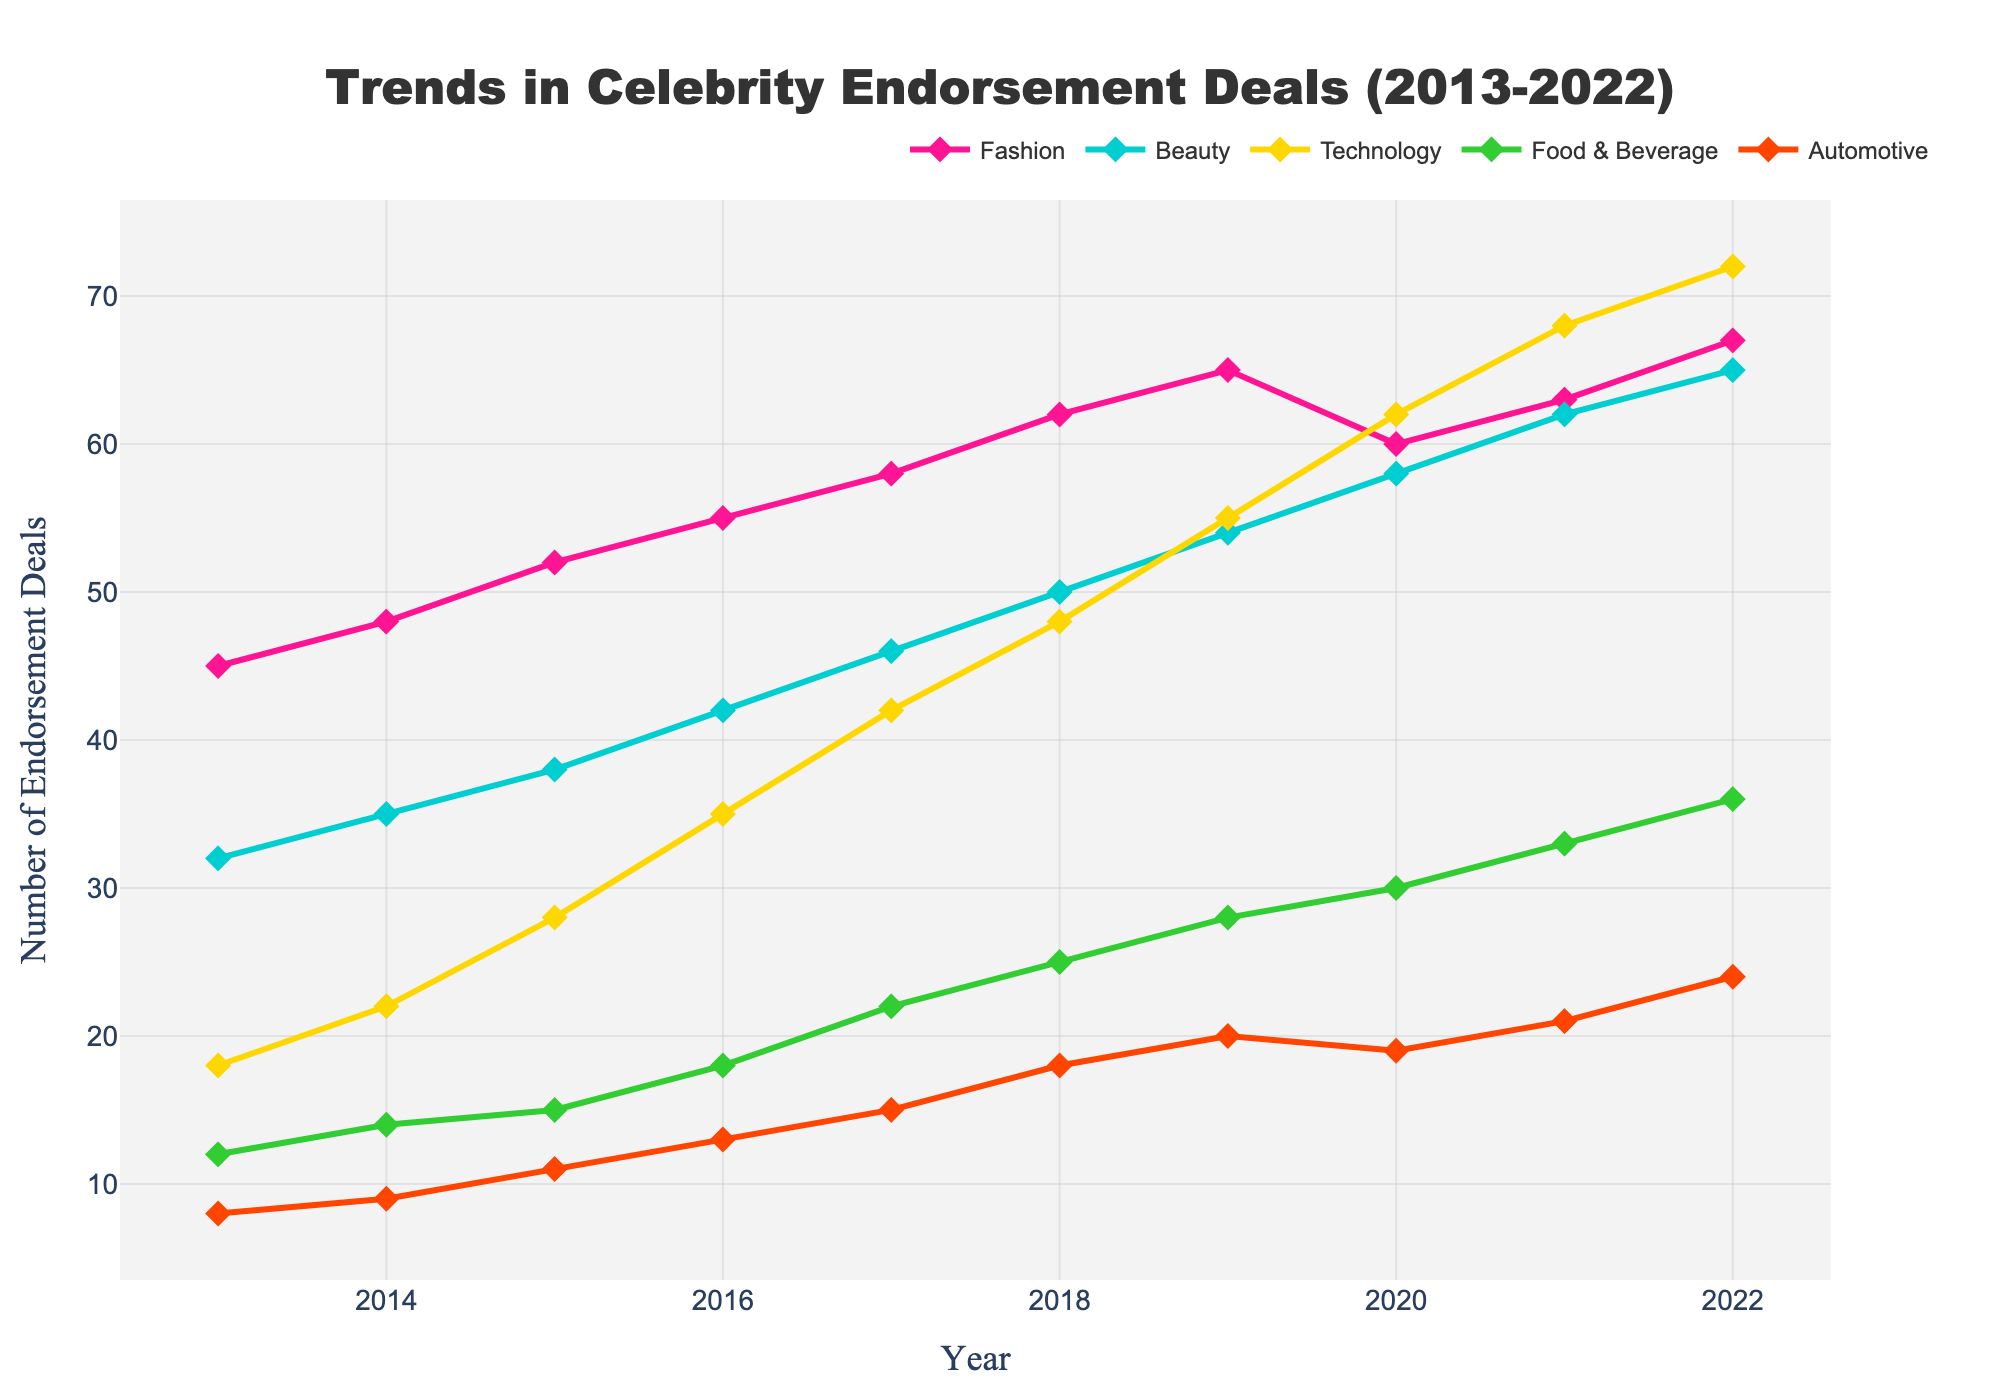Which industry had the highest number of celebrity endorsement deals in 2022? Look at the endpoints of each line in 2022 and identify the one with the highest value. Technology has the highest value at 72.
Answer: Technology Which industry saw the least increase in endorsement deals from 2013 to 2022? Calculate the increase for each industry by subtracting the 2013 value from the 2022 value. The increases are: Fashion (22), Beauty (33), Technology (54), Food & Beverage (24), Automotive (16). Automotive has the smallest increase.
Answer: Automotive What is the total number of endorsement deals across all industries in 2017? Sum the values for all industries in 2017: 58 (Fashion) + 46 (Beauty) + 42 (Technology) + 22 (Food & Beverage) + 15 (Automotive) = 183.
Answer: 183 How did the number of endorsement deals in the Beauty industry change between 2019 and 2020? Subtract the value in 2019 from the value in 2020 for the Beauty industry: 58 - 54 = 4.
Answer: Increased by 4 Which industry experienced the most significant drop in a single year? Identify the drop by looking for the most significant decrease between any two consecutive years. Fashion dropped from 65 in 2019 to 60 in 2020, which is a decrease of 5.
Answer: Fashion In which year did the Food & Beverage industry see its highest growth rate? Calculate the year-by-year growth for Food & Beverage and determine the maximum. The greatest growth is from 2016 to 2017, with an increase of 4 (22 - 18).
Answer: 2017 What is the average number of endorsement deals in the Technology industry over the entire decade? Sum the values for each year in Technology and then divide by the number of years: (18 + 22 + 28 + 35 + 42 + 48 + 55 + 62 + 68 + 72)/10 = 45.
Answer: 45 Did any industry see a continuous increase over the entire period? Check the trend for each industry year by year. No industry saw a continuous increase without any drop over the decade.
Answer: No Between Fashion and Beauty, which industry had a higher growth rate from 2015 to 2022? Calculate the growth for each industry: Fashion (67 - 52 = 15) and Beauty (65 - 38 = 27). Beauty has a higher growth.
Answer: Beauty 